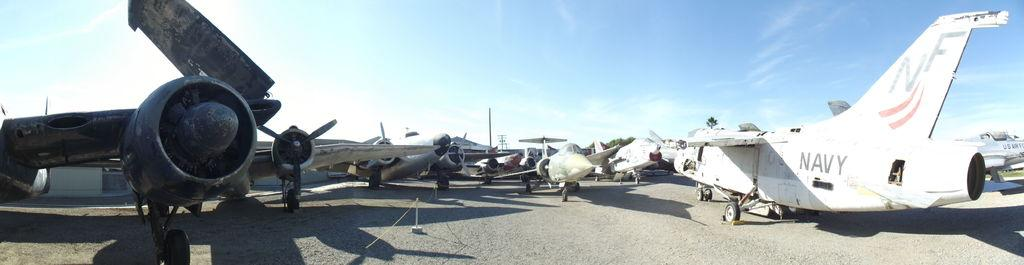<image>
Relay a brief, clear account of the picture shown. a plane that has the letters NF on it 